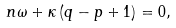<formula> <loc_0><loc_0><loc_500><loc_500>n \omega + \kappa \left ( q - p + 1 \right ) = 0 ,</formula> 